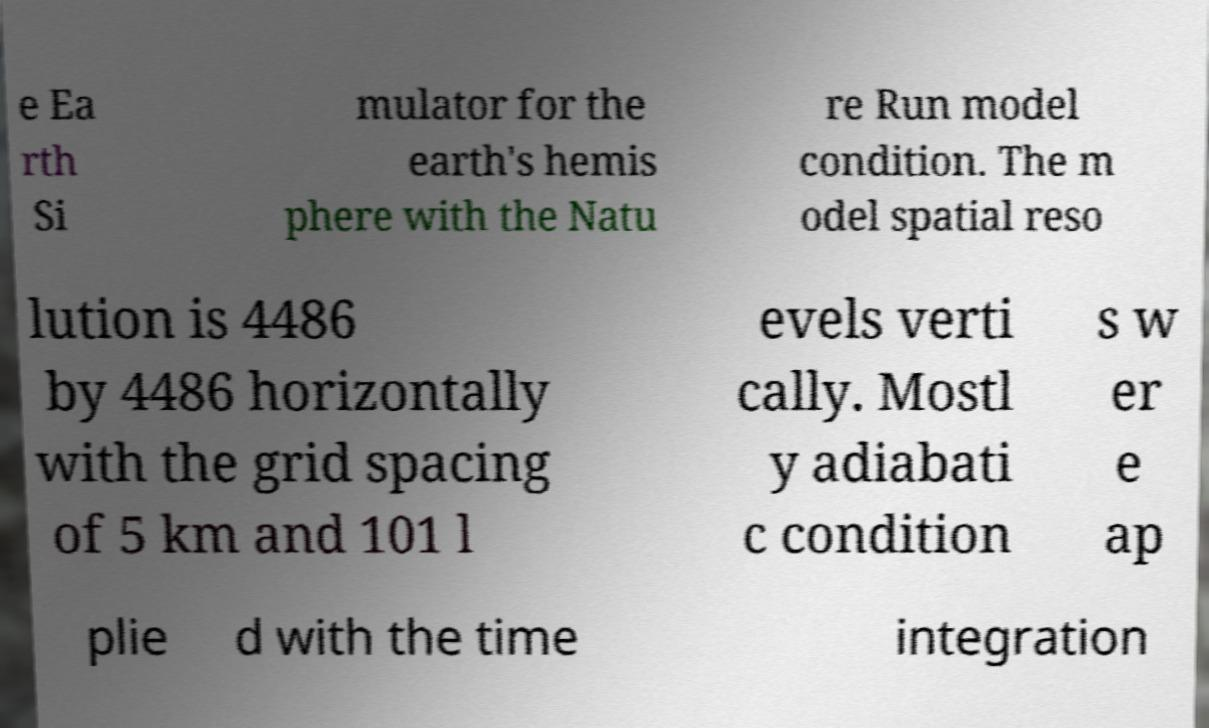There's text embedded in this image that I need extracted. Can you transcribe it verbatim? e Ea rth Si mulator for the earth's hemis phere with the Natu re Run model condition. The m odel spatial reso lution is 4486 by 4486 horizontally with the grid spacing of 5 km and 101 l evels verti cally. Mostl y adiabati c condition s w er e ap plie d with the time integration 